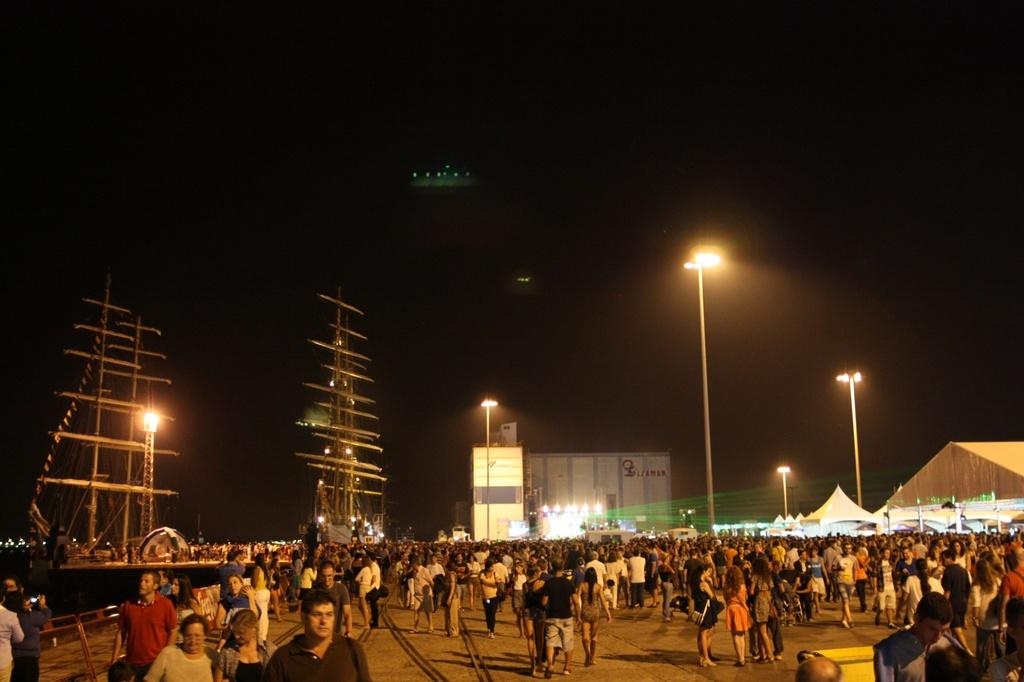What is there are many people standing at the bottom of the image, what are they doing? There are many people standing at the bottom of the image, but their specific actions are not clear from the provided facts. What is the purpose of the street light in the image? The purpose of the street light in the image is not mentioned in the provided facts. What type of building can be seen in the background of the image? The type of building in the background of the image is not specified in the provided facts. What type of cloth is draped over the steel structure in the image? There is no steel structure or cloth present in the image. 